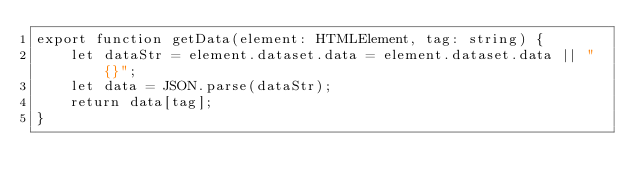<code> <loc_0><loc_0><loc_500><loc_500><_TypeScript_>export function getData(element: HTMLElement, tag: string) {
    let dataStr = element.dataset.data = element.dataset.data || "{}";
    let data = JSON.parse(dataStr);
    return data[tag];
}
</code> 